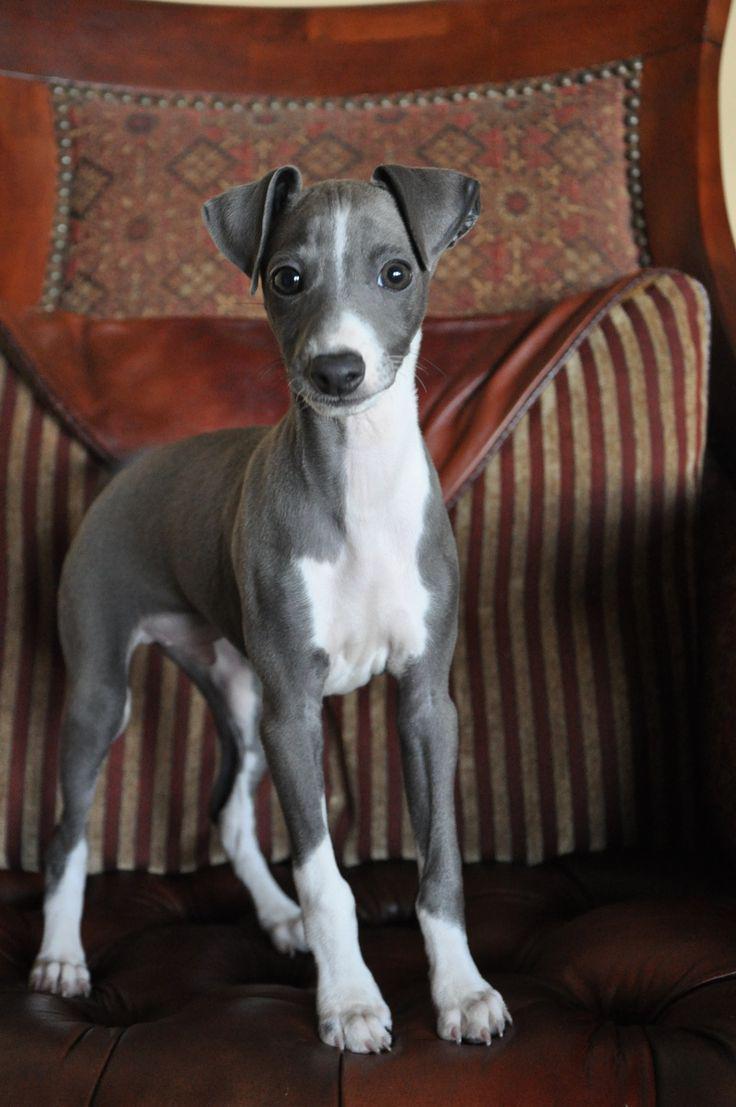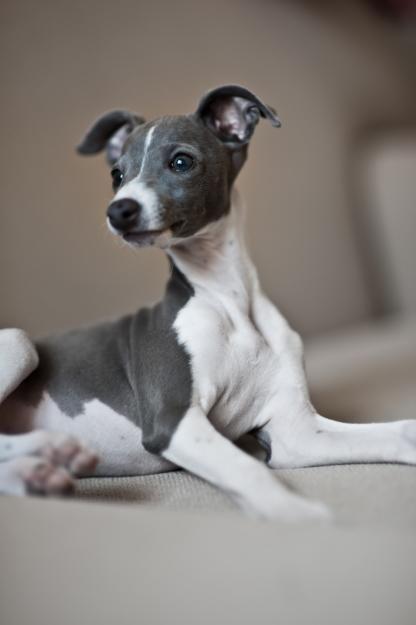The first image is the image on the left, the second image is the image on the right. For the images shown, is this caption "The dog in one of the images is holding one paw up." true? Answer yes or no. No. The first image is the image on the left, the second image is the image on the right. For the images shown, is this caption "At least one image in the pair contains a dog standing up with all four legs on the ground." true? Answer yes or no. Yes. 